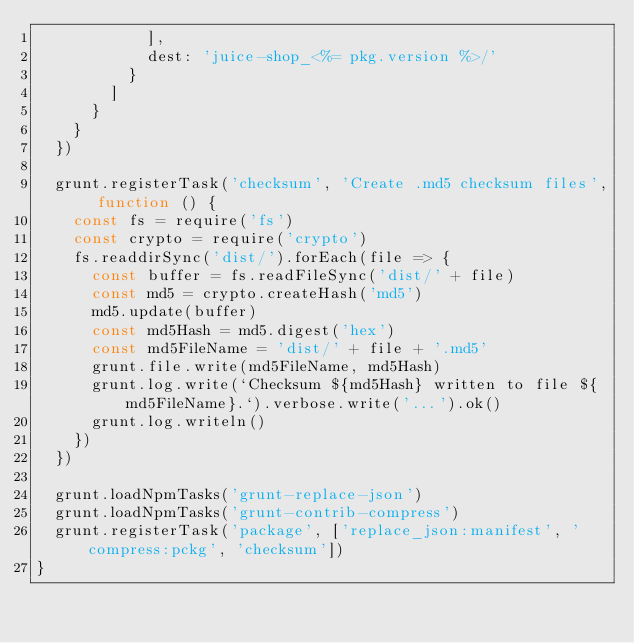Convert code to text. <code><loc_0><loc_0><loc_500><loc_500><_JavaScript_>            ],
            dest: 'juice-shop_<%= pkg.version %>/'
          }
        ]
      }
    }
  })

  grunt.registerTask('checksum', 'Create .md5 checksum files', function () {
    const fs = require('fs')
    const crypto = require('crypto')
    fs.readdirSync('dist/').forEach(file => {
      const buffer = fs.readFileSync('dist/' + file)
      const md5 = crypto.createHash('md5')
      md5.update(buffer)
      const md5Hash = md5.digest('hex')
      const md5FileName = 'dist/' + file + '.md5'
      grunt.file.write(md5FileName, md5Hash)
      grunt.log.write(`Checksum ${md5Hash} written to file ${md5FileName}.`).verbose.write('...').ok()
      grunt.log.writeln()
    })
  })

  grunt.loadNpmTasks('grunt-replace-json')
  grunt.loadNpmTasks('grunt-contrib-compress')
  grunt.registerTask('package', ['replace_json:manifest', 'compress:pckg', 'checksum'])
}
</code> 